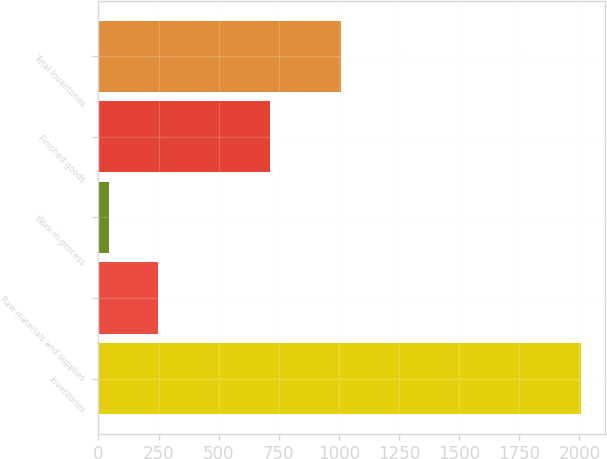Convert chart. <chart><loc_0><loc_0><loc_500><loc_500><bar_chart><fcel>Inventories<fcel>Raw materials and supplies<fcel>Work-in-process<fcel>Finished goods<fcel>Total Inventories<nl><fcel>2006<fcel>248.3<fcel>45.4<fcel>714.7<fcel>1008.4<nl></chart> 